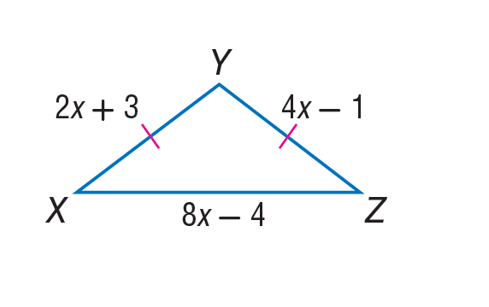Answer the mathemtical geometry problem and directly provide the correct option letter.
Question: Find Y Z of isosceles \triangle X Y Z.
Choices: A: 1 B: 7 C: 8 D: 9 B 